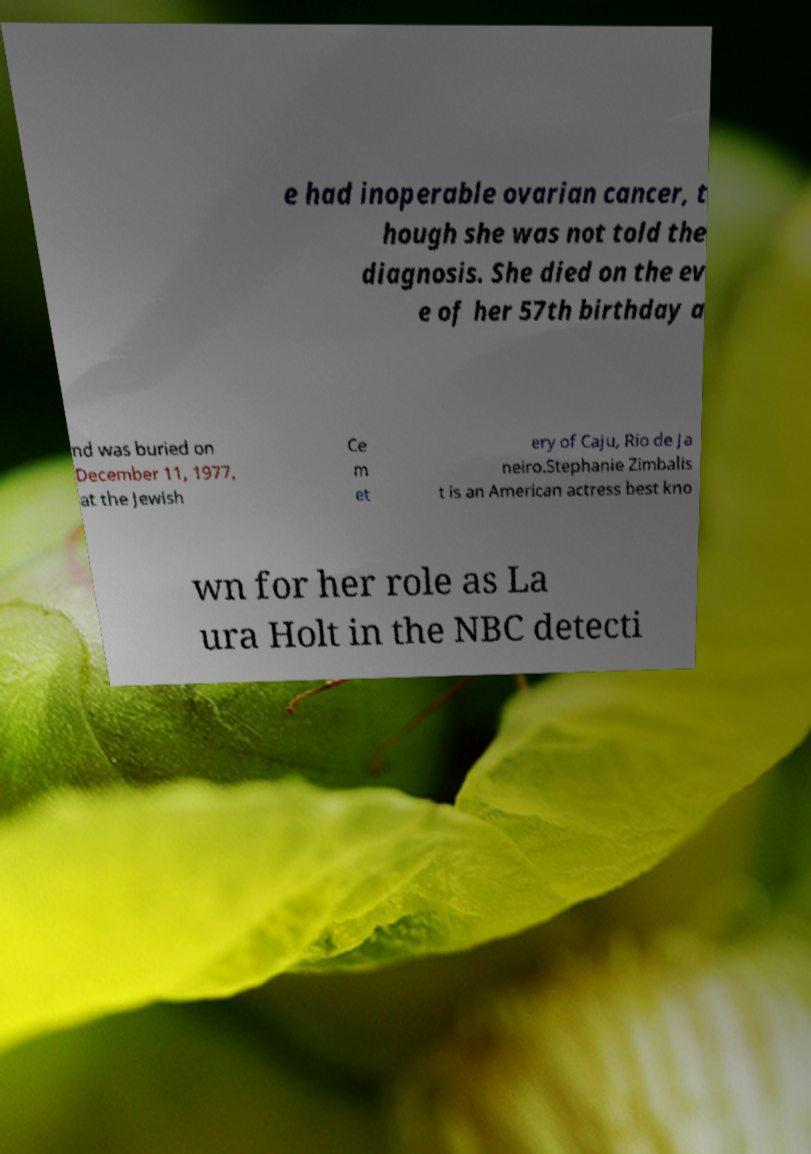What messages or text are displayed in this image? I need them in a readable, typed format. e had inoperable ovarian cancer, t hough she was not told the diagnosis. She died on the ev e of her 57th birthday a nd was buried on December 11, 1977, at the Jewish Ce m et ery of Caju, Rio de Ja neiro.Stephanie Zimbalis t is an American actress best kno wn for her role as La ura Holt in the NBC detecti 